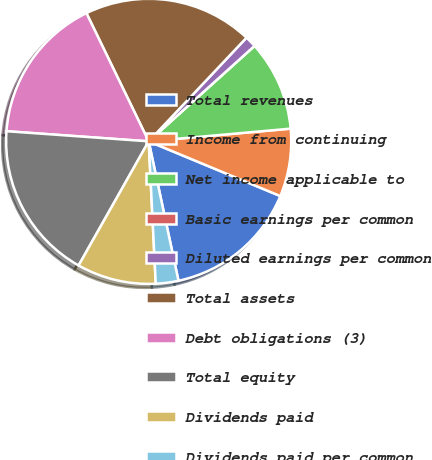Convert chart. <chart><loc_0><loc_0><loc_500><loc_500><pie_chart><fcel>Total revenues<fcel>Income from continuing<fcel>Net income applicable to<fcel>Basic earnings per common<fcel>Diluted earnings per common<fcel>Total assets<fcel>Debt obligations (3)<fcel>Total equity<fcel>Dividends paid<fcel>Dividends paid per common<nl><fcel>15.38%<fcel>7.69%<fcel>10.26%<fcel>0.0%<fcel>1.28%<fcel>19.23%<fcel>16.67%<fcel>17.95%<fcel>8.97%<fcel>2.56%<nl></chart> 